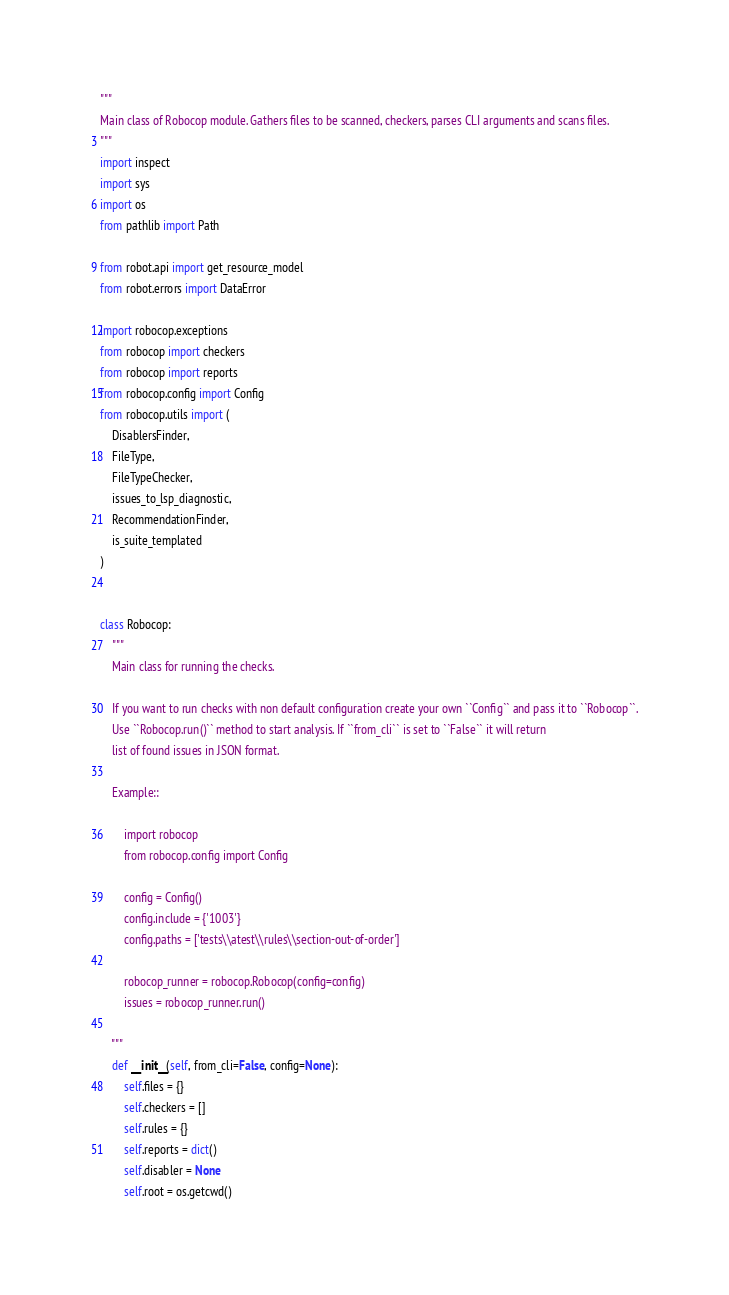<code> <loc_0><loc_0><loc_500><loc_500><_Python_>"""
Main class of Robocop module. Gathers files to be scanned, checkers, parses CLI arguments and scans files.
"""
import inspect
import sys
import os
from pathlib import Path

from robot.api import get_resource_model
from robot.errors import DataError

import robocop.exceptions
from robocop import checkers
from robocop import reports
from robocop.config import Config
from robocop.utils import (
    DisablersFinder,
    FileType,
    FileTypeChecker,
    issues_to_lsp_diagnostic,
    RecommendationFinder,
    is_suite_templated
)


class Robocop:
    """
    Main class for running the checks.

    If you want to run checks with non default configuration create your own ``Config`` and pass it to ``Robocop``.
    Use ``Robocop.run()`` method to start analysis. If ``from_cli`` is set to ``False`` it will return
    list of found issues in JSON format.

    Example::

        import robocop
        from robocop.config import Config

        config = Config()
        config.include = {'1003'}
        config.paths = ['tests\\atest\\rules\\section-out-of-order']

        robocop_runner = robocop.Robocop(config=config)
        issues = robocop_runner.run()

    """
    def __init__(self, from_cli=False, config=None):
        self.files = {}
        self.checkers = []
        self.rules = {}
        self.reports = dict()
        self.disabler = None
        self.root = os.getcwd()</code> 